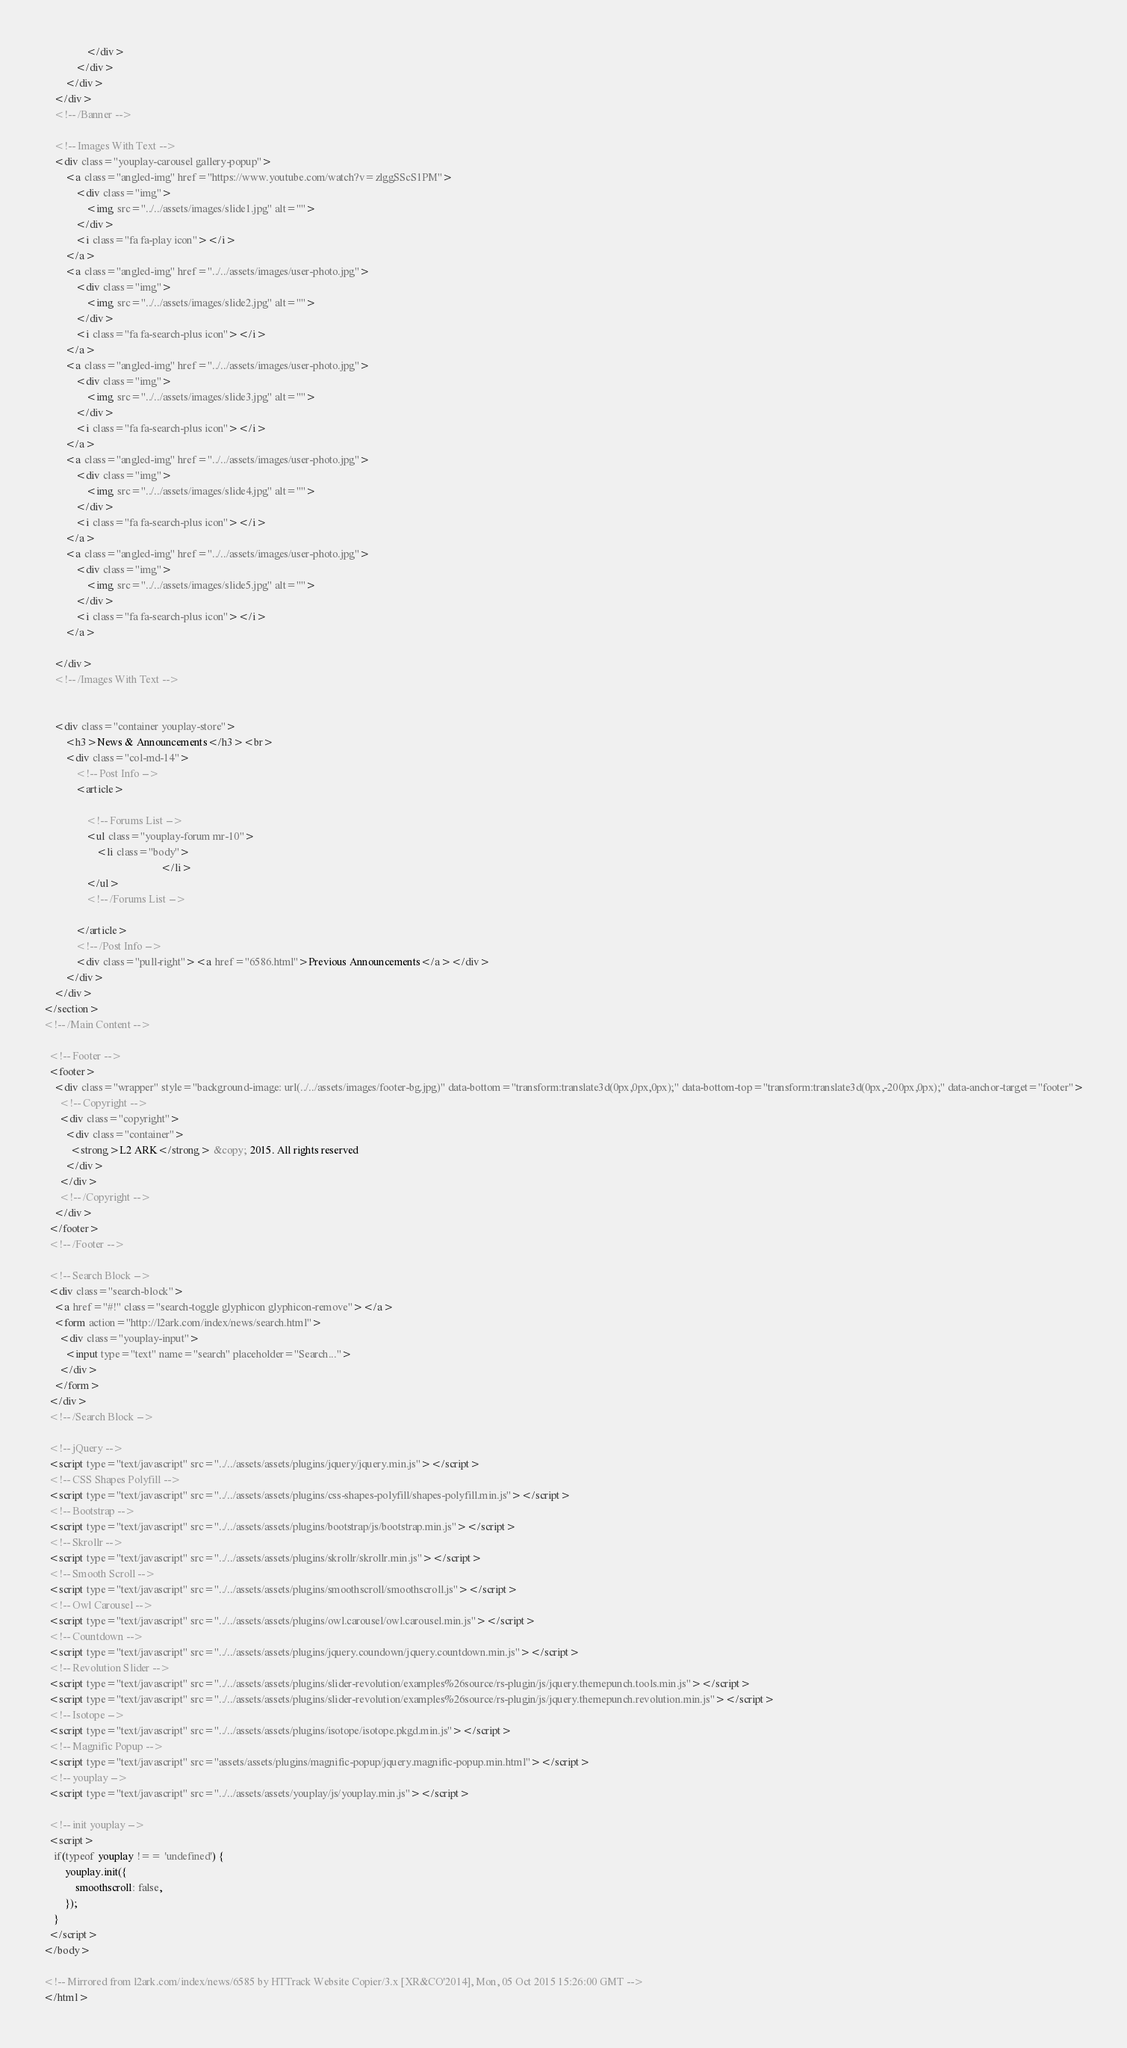<code> <loc_0><loc_0><loc_500><loc_500><_HTML_>                </div>
            </div>
        </div>
    </div>
    <!-- /Banner -->

    <!-- Images With Text -->
    <div class="youplay-carousel gallery-popup">
        <a class="angled-img" href="https://www.youtube.com/watch?v=zlggSScS1PM">
            <div class="img">
                <img src="../../assets/images/slide1.jpg" alt="">
            </div>
            <i class="fa fa-play icon"></i>
        </a>
        <a class="angled-img" href="../../assets/images/user-photo.jpg">
            <div class="img">
                <img src="../../assets/images/slide2.jpg" alt="">
            </div>
            <i class="fa fa-search-plus icon"></i>
        </a>
        <a class="angled-img" href="../../assets/images/user-photo.jpg">
            <div class="img">
                <img src="../../assets/images/slide3.jpg" alt="">
            </div>
            <i class="fa fa-search-plus icon"></i>
        </a>
        <a class="angled-img" href="../../assets/images/user-photo.jpg">
            <div class="img">
                <img src="../../assets/images/slide4.jpg" alt="">
            </div>
            <i class="fa fa-search-plus icon"></i>
        </a>
        <a class="angled-img" href="../../assets/images/user-photo.jpg">
            <div class="img">
                <img src="../../assets/images/slide5.jpg" alt="">
            </div>
            <i class="fa fa-search-plus icon"></i>
        </a>

    </div>
    <!-- /Images With Text -->


    <div class="container youplay-store">
        <h3>News & Announcements</h3><br>
        <div class="col-md-14">
            <!-- Post Info -->
            <article>

                <!-- Forums List -->
                <ul class="youplay-forum mr-10">
                    <li class="body">
                                            </li>
                </ul>
                <!-- /Forums List -->
                
            </article>
            <!-- /Post Info -->
            <div class="pull-right"><a href="6586.html">Previous Announcements</a></div>
        </div>
    </div>
</section>
<!-- /Main Content -->

  <!-- Footer -->
  <footer>
    <div class="wrapper" style="background-image: url(../../assets/images/footer-bg.jpg)" data-bottom="transform:translate3d(0px,0px,0px);" data-bottom-top="transform:translate3d(0px,-200px,0px);" data-anchor-target="footer">
      <!-- Copyright -->
      <div class="copyright">
        <div class="container">
          <strong>L2 ARK</strong> &copy; 2015. All rights reserved
        </div>
      </div>
      <!-- /Copyright -->
    </div>
  </footer>
  <!-- /Footer -->

  <!-- Search Block -->
  <div class="search-block">
    <a href="#!" class="search-toggle glyphicon glyphicon-remove"></a>
    <form action="http://l2ark.com/index/news/search.html">
      <div class="youplay-input">
        <input type="text" name="search" placeholder="Search...">
      </div>
    </form>
  </div>
  <!-- /Search Block -->
  
  <!-- jQuery -->
  <script type="text/javascript" src="../../assets/assets/plugins/jquery/jquery.min.js"></script>
  <!-- CSS Shapes Polyfill -->
  <script type="text/javascript" src="../../assets/assets/plugins/css-shapes-polyfill/shapes-polyfill.min.js"></script>
  <!-- Bootstrap -->
  <script type="text/javascript" src="../../assets/assets/plugins/bootstrap/js/bootstrap.min.js"></script>
  <!-- Skrollr -->
  <script type="text/javascript" src="../../assets/assets/plugins/skrollr/skrollr.min.js"></script>
  <!-- Smooth Scroll -->
  <script type="text/javascript" src="../../assets/assets/plugins/smoothscroll/smoothscroll.js"></script>
  <!-- Owl Carousel -->
  <script type="text/javascript" src="../../assets/assets/plugins/owl.carousel/owl.carousel.min.js"></script>
  <!-- Countdown -->
  <script type="text/javascript" src="../../assets/assets/plugins/jquery.coundown/jquery.countdown.min.js"></script>
  <!-- Revolution Slider -->
  <script type="text/javascript" src="../../assets/assets/plugins/slider-revolution/examples%26source/rs-plugin/js/jquery.themepunch.tools.min.js"></script>
  <script type="text/javascript" src="../../assets/assets/plugins/slider-revolution/examples%26source/rs-plugin/js/jquery.themepunch.revolution.min.js"></script>
  <!-- Isotope -->
  <script type="text/javascript" src="../../assets/assets/plugins/isotope/isotope.pkgd.min.js"></script>
  <!-- Magnific Popup -->
  <script type="text/javascript" src="assets/assets/plugins/magnific-popup/jquery.magnific-popup.min.html"></script>
  <!-- youplay -->
  <script type="text/javascript" src="../../assets/assets/youplay/js/youplay.min.js"></script>

  <!-- init youplay -->
  <script>
    if(typeof youplay !== 'undefined') {
        youplay.init({
            smoothscroll: false,
        });
    }
  </script>
</body>

<!-- Mirrored from l2ark.com/index/news/6585 by HTTrack Website Copier/3.x [XR&CO'2014], Mon, 05 Oct 2015 15:26:00 GMT -->
</html></code> 